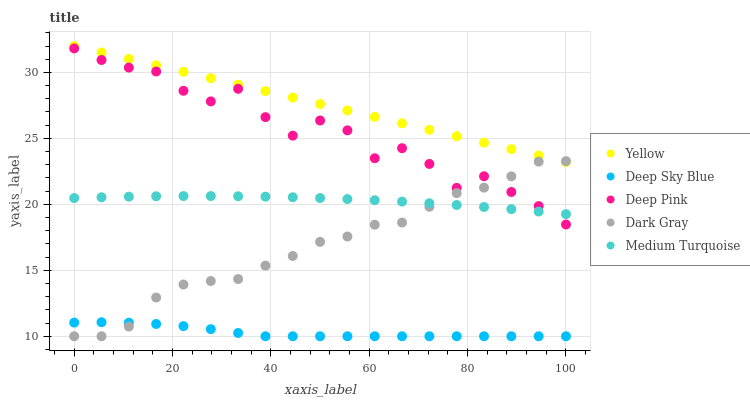Does Deep Sky Blue have the minimum area under the curve?
Answer yes or no. Yes. Does Yellow have the maximum area under the curve?
Answer yes or no. Yes. Does Medium Turquoise have the minimum area under the curve?
Answer yes or no. No. Does Medium Turquoise have the maximum area under the curve?
Answer yes or no. No. Is Yellow the smoothest?
Answer yes or no. Yes. Is Deep Pink the roughest?
Answer yes or no. Yes. Is Medium Turquoise the smoothest?
Answer yes or no. No. Is Medium Turquoise the roughest?
Answer yes or no. No. Does Dark Gray have the lowest value?
Answer yes or no. Yes. Does Medium Turquoise have the lowest value?
Answer yes or no. No. Does Yellow have the highest value?
Answer yes or no. Yes. Does Medium Turquoise have the highest value?
Answer yes or no. No. Is Deep Sky Blue less than Deep Pink?
Answer yes or no. Yes. Is Yellow greater than Deep Sky Blue?
Answer yes or no. Yes. Does Dark Gray intersect Yellow?
Answer yes or no. Yes. Is Dark Gray less than Yellow?
Answer yes or no. No. Is Dark Gray greater than Yellow?
Answer yes or no. No. Does Deep Sky Blue intersect Deep Pink?
Answer yes or no. No. 